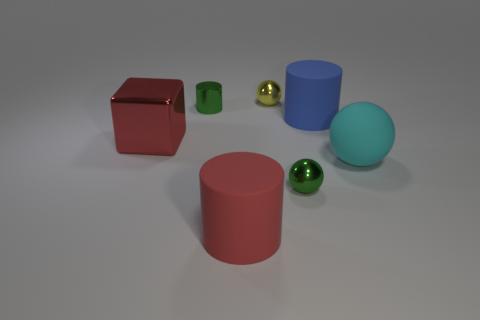There is a object that is the same color as the shiny cylinder; what is its size?
Your response must be concise. Small. Is there a big matte cylinder that has the same color as the rubber sphere?
Offer a very short reply. No. There is a sphere that is the same size as the yellow shiny object; what color is it?
Provide a short and direct response. Green. Are the yellow thing right of the red cylinder and the large blue cylinder made of the same material?
Ensure brevity in your answer.  No. Is there a rubber ball in front of the big cylinder in front of the cylinder that is to the right of the red rubber cylinder?
Keep it short and to the point. No. Is the shape of the large red matte thing to the left of the small green ball the same as  the big cyan thing?
Provide a short and direct response. No. There is a green object that is on the left side of the small green metallic thing on the right side of the green cylinder; what shape is it?
Provide a short and direct response. Cylinder. There is a green metal object on the right side of the yellow ball on the left side of the green thing that is to the right of the green metal cylinder; how big is it?
Offer a terse response. Small. There is another large matte thing that is the same shape as the blue matte thing; what is its color?
Keep it short and to the point. Red. Do the cyan rubber ball and the red rubber cylinder have the same size?
Give a very brief answer. Yes. 